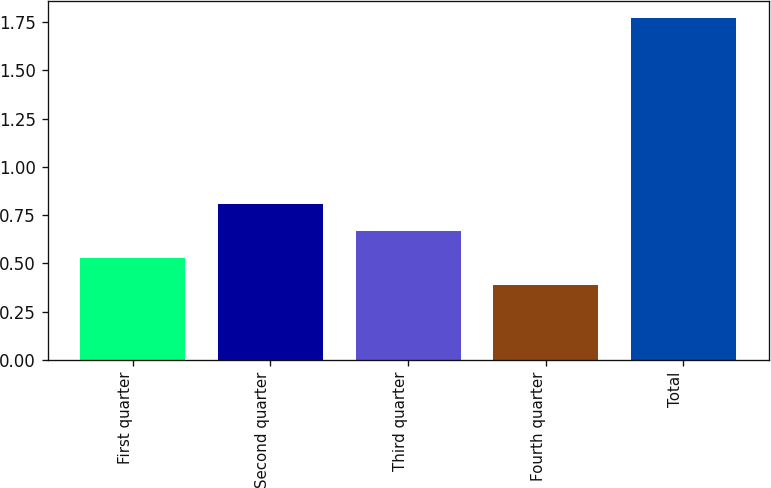Convert chart to OTSL. <chart><loc_0><loc_0><loc_500><loc_500><bar_chart><fcel>First quarter<fcel>Second quarter<fcel>Third quarter<fcel>Fourth quarter<fcel>Total<nl><fcel>0.53<fcel>0.81<fcel>0.67<fcel>0.39<fcel>1.77<nl></chart> 